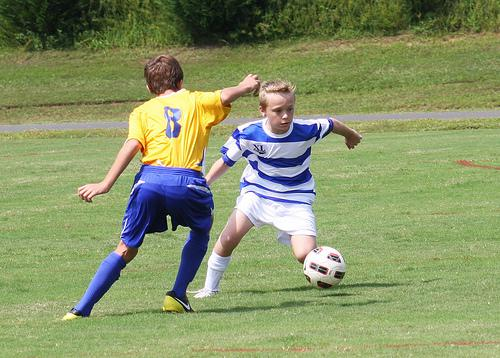Question: what sport are the two boys playing?
Choices:
A. Tennis.
B. Soccer.
C. Kickball.
D. Dodgeball.
Answer with the letter. Answer: B Question: how many boys are in the picture?
Choices:
A. One.
B. Six.
C. Four.
D. Two.
Answer with the letter. Answer: D Question: where are the two boys playing?
Choices:
A. In a pool.
B. At a park.
C. In school.
D. In a park.
Answer with the letter. Answer: B Question: what color is the number 8?
Choices:
A. Yellow.
B. Green.
C. Blue.
D. Red.
Answer with the letter. Answer: C Question: how many socks are visible?
Choices:
A. Three.
B. Two.
C. Six.
D. One.
Answer with the letter. Answer: A 